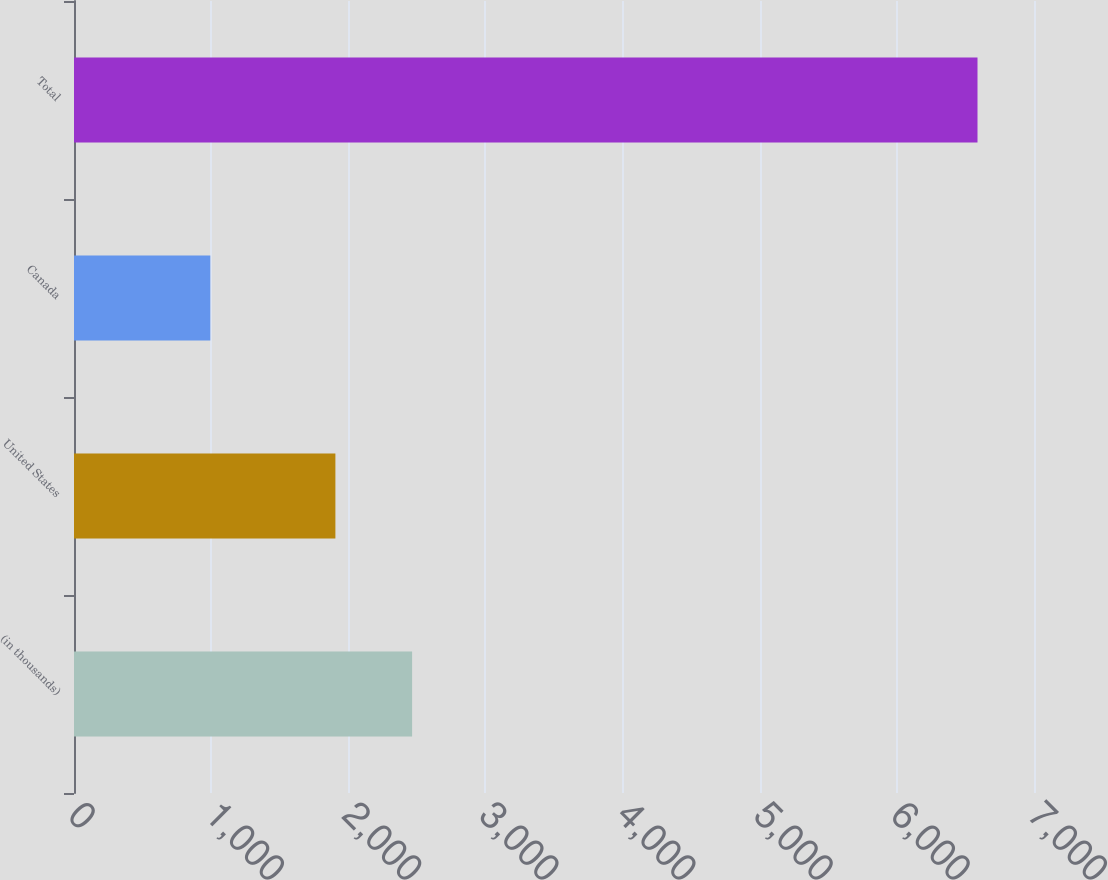Convert chart to OTSL. <chart><loc_0><loc_0><loc_500><loc_500><bar_chart><fcel>(in thousands)<fcel>United States<fcel>Canada<fcel>Total<nl><fcel>2465.4<fcel>1906<fcel>994<fcel>6588<nl></chart> 